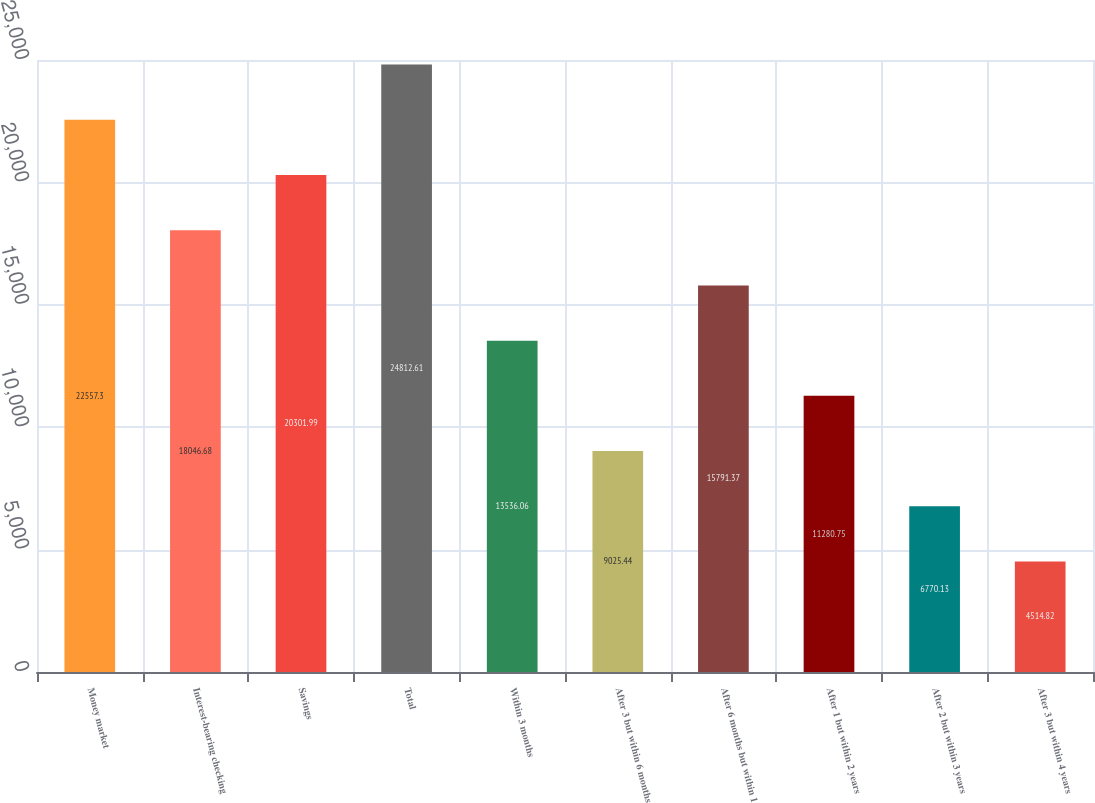<chart> <loc_0><loc_0><loc_500><loc_500><bar_chart><fcel>Money market<fcel>Interest-bearing checking<fcel>Savings<fcel>Total<fcel>Within 3 months<fcel>After 3 but within 6 months<fcel>After 6 months but within 1<fcel>After 1 but within 2 years<fcel>After 2 but within 3 years<fcel>After 3 but within 4 years<nl><fcel>22557.3<fcel>18046.7<fcel>20302<fcel>24812.6<fcel>13536.1<fcel>9025.44<fcel>15791.4<fcel>11280.8<fcel>6770.13<fcel>4514.82<nl></chart> 